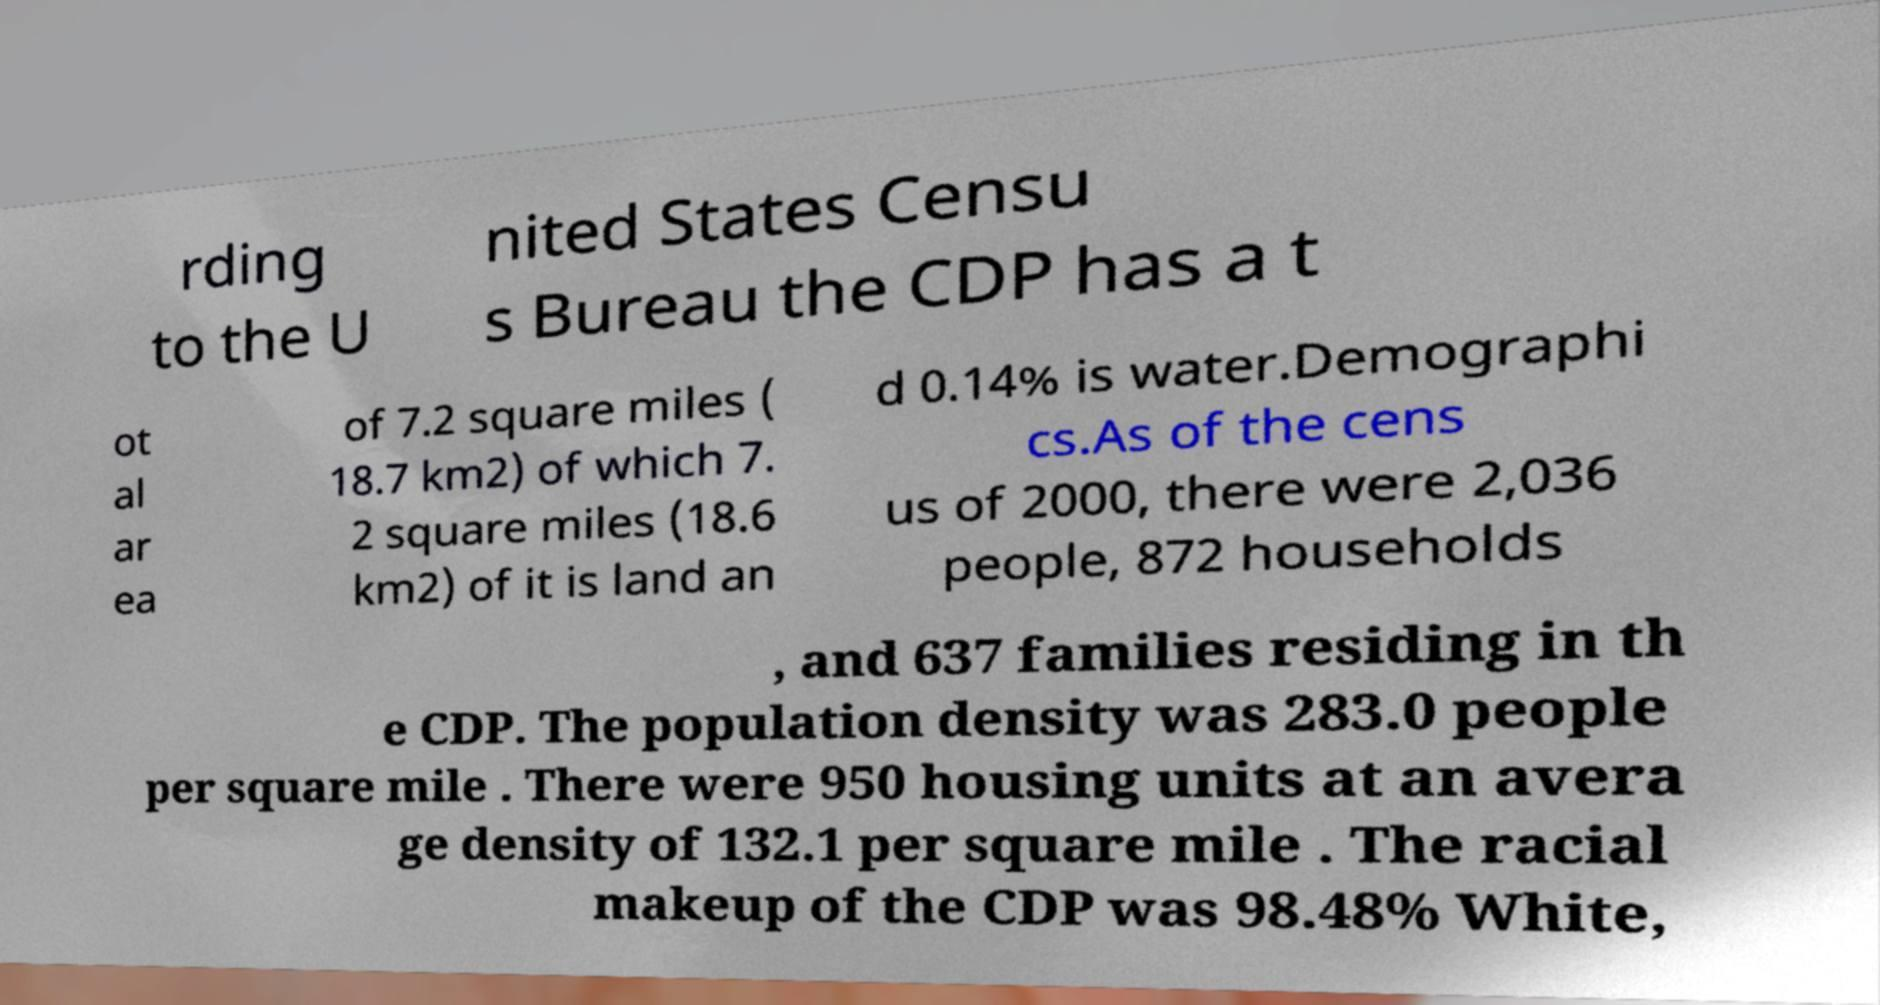I need the written content from this picture converted into text. Can you do that? rding to the U nited States Censu s Bureau the CDP has a t ot al ar ea of 7.2 square miles ( 18.7 km2) of which 7. 2 square miles (18.6 km2) of it is land an d 0.14% is water.Demographi cs.As of the cens us of 2000, there were 2,036 people, 872 households , and 637 families residing in th e CDP. The population density was 283.0 people per square mile . There were 950 housing units at an avera ge density of 132.1 per square mile . The racial makeup of the CDP was 98.48% White, 